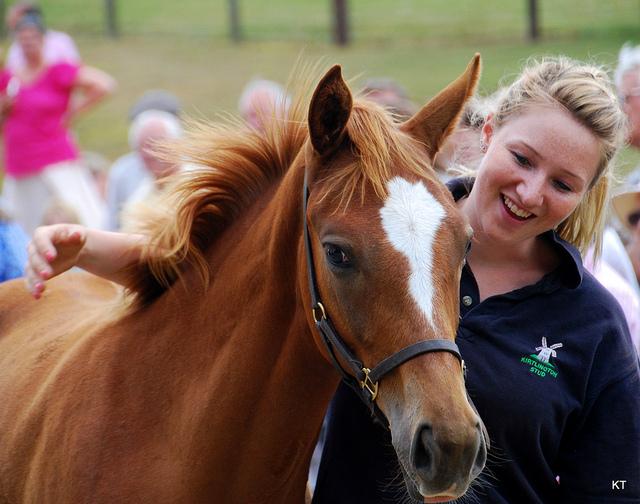Does the horses hair match the girls hair in color?
Quick response, please. No. Is this woman enjoying herself?
Concise answer only. Yes. Is the horse bigger than the girl?
Short answer required. Yes. What's around the horse's head?
Short answer required. Bridle. How many teeth do you see?
Short answer required. 7. Does the horse belong to the girl?
Short answer required. Yes. 